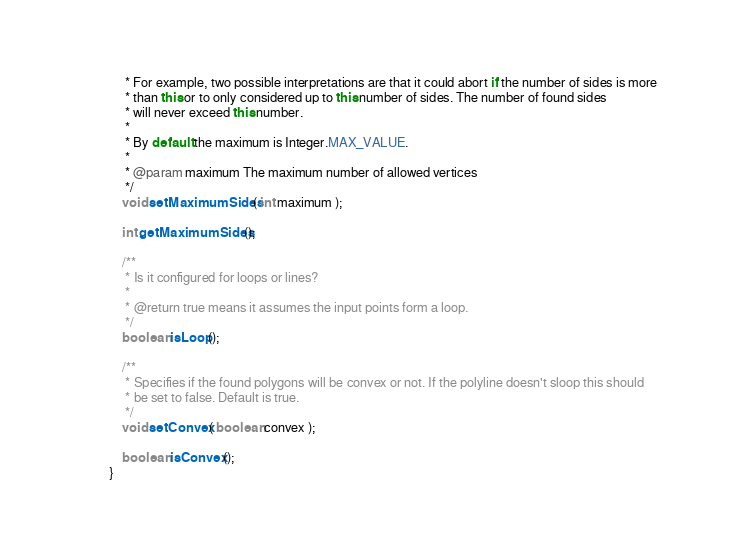<code> <loc_0><loc_0><loc_500><loc_500><_Java_>	 * For example, two possible interpretations are that it could abort if the number of sides is more
	 * than this or to only considered up to this number of sides. The number of found sides
	 * will never exceed this number.
	 *
	 * By default the maximum is Integer.MAX_VALUE.
	 *
	 * @param maximum The maximum number of allowed vertices
	 */
	void setMaximumSides( int maximum );

	int getMaximumSides();

	/**
	 * Is it configured for loops or lines?
	 *
	 * @return true means it assumes the input points form a loop.
	 */
	boolean isLoop();

	/**
	 * Specifies if the found polygons will be convex or not. If the polyline doesn't sloop this should
	 * be set to false. Default is true.
	 */
	void setConvex( boolean convex );

	boolean isConvex();
}
</code> 